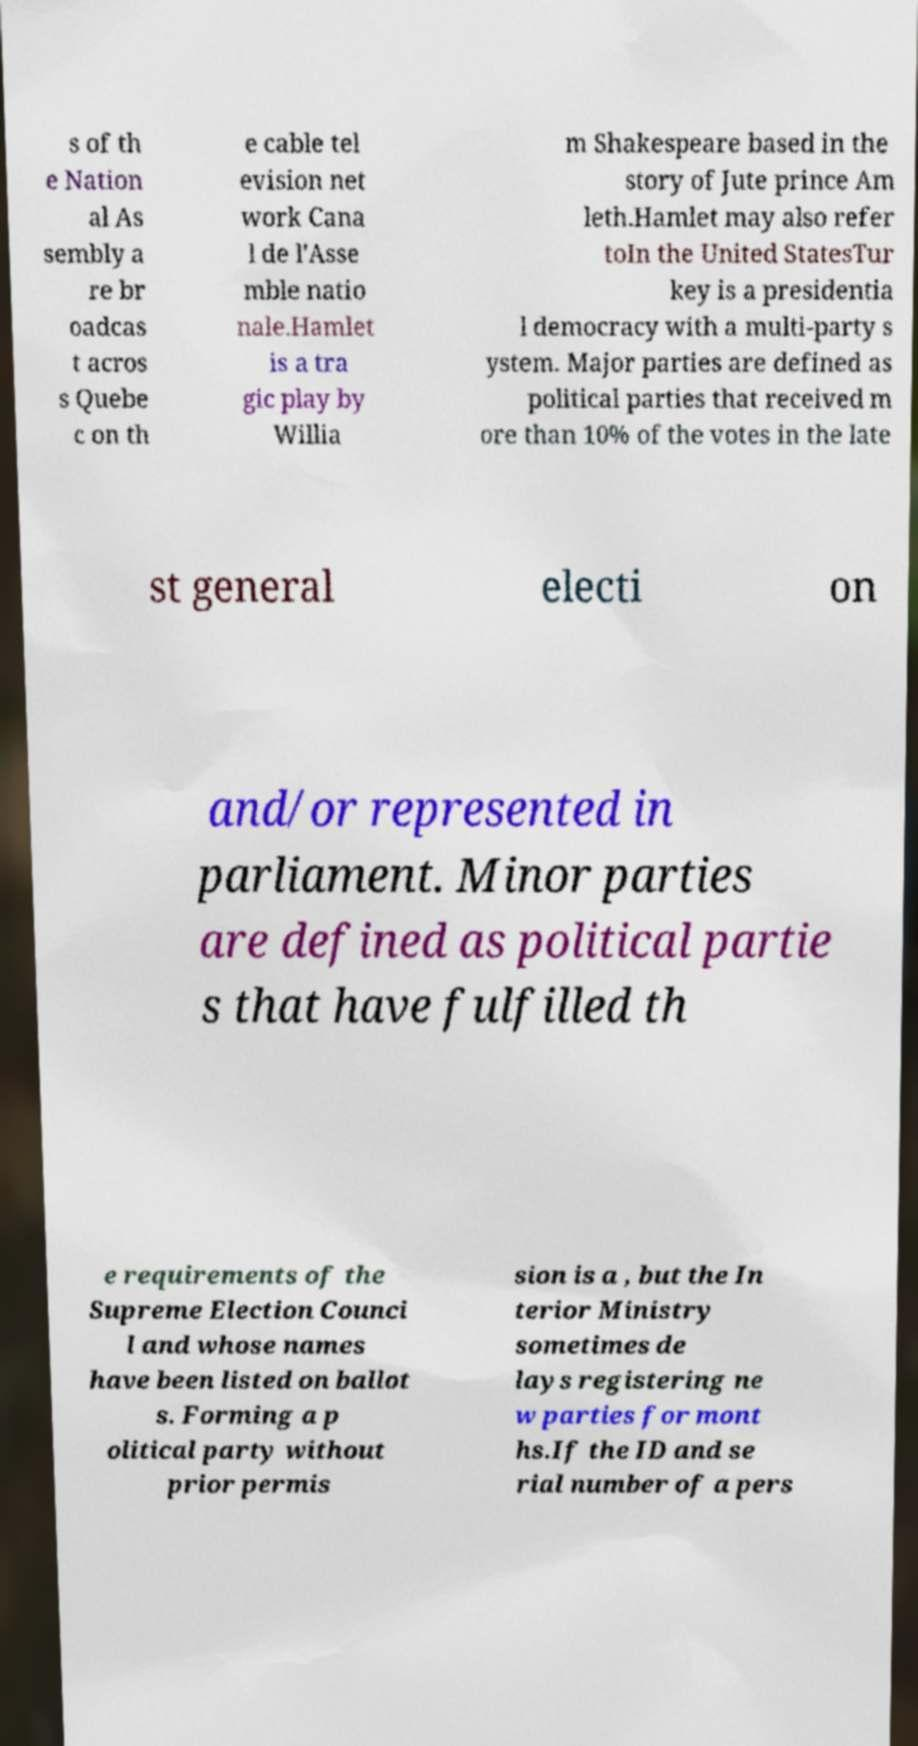Can you read and provide the text displayed in the image?This photo seems to have some interesting text. Can you extract and type it out for me? s of th e Nation al As sembly a re br oadcas t acros s Quebe c on th e cable tel evision net work Cana l de l'Asse mble natio nale.Hamlet is a tra gic play by Willia m Shakespeare based in the story of Jute prince Am leth.Hamlet may also refer toIn the United StatesTur key is a presidentia l democracy with a multi-party s ystem. Major parties are defined as political parties that received m ore than 10% of the votes in the late st general electi on and/or represented in parliament. Minor parties are defined as political partie s that have fulfilled th e requirements of the Supreme Election Counci l and whose names have been listed on ballot s. Forming a p olitical party without prior permis sion is a , but the In terior Ministry sometimes de lays registering ne w parties for mont hs.If the ID and se rial number of a pers 